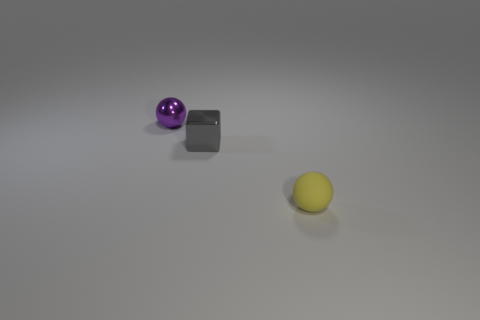Do the purple sphere and the gray metallic block have the same size? Upon visual inspection of the image, the purple sphere and the gray metallic block do not appear to have the same size. The purple sphere seems slightly smaller in comparison to the dimensions of the gray block. 